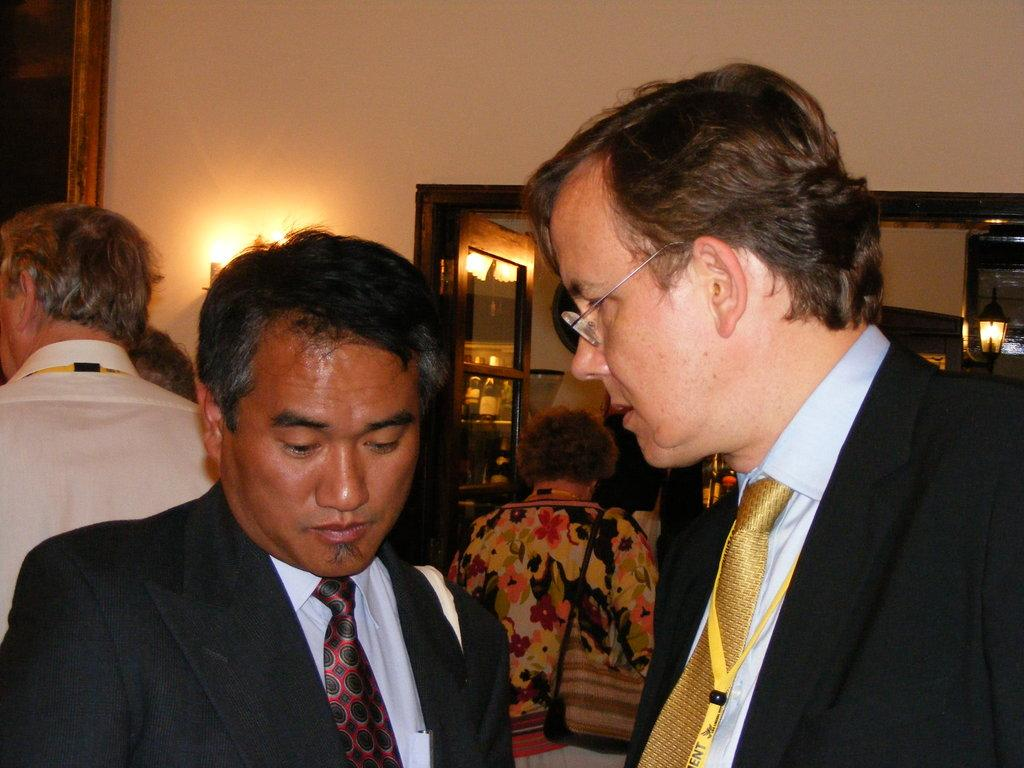How many people are in the image? There is a group of people in the image. What are the people wearing? The people are wearing different color dresses. What can be seen in the background of the image? There are lights, a wall, and bottles in a rack in the background of the image. How many geese are sitting on the beds in the image? There are no geese or beds present in the image. What type of key is being used to open the door in the image? There is no door or key present in the image. 